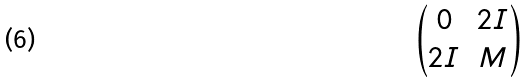Convert formula to latex. <formula><loc_0><loc_0><loc_500><loc_500>\begin{pmatrix} 0 & 2 I \\ 2 I & M \end{pmatrix}</formula> 